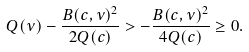Convert formula to latex. <formula><loc_0><loc_0><loc_500><loc_500>Q ( \nu ) - \frac { B ( c , \nu ) ^ { 2 } } { 2 Q ( c ) } > - \frac { B ( c , \nu ) ^ { 2 } } { 4 Q ( c ) } \geq 0 .</formula> 